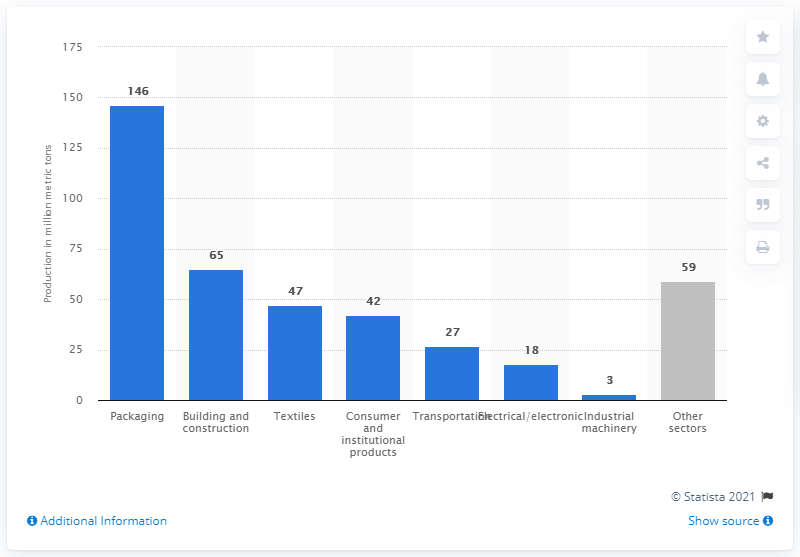Specify some key components in this picture. In 2017, the global production of plastics for packaging reached 146 million metric tons. In 2017, the global production of plastics for the building and construction sector was approximately 65 million metric tons. 